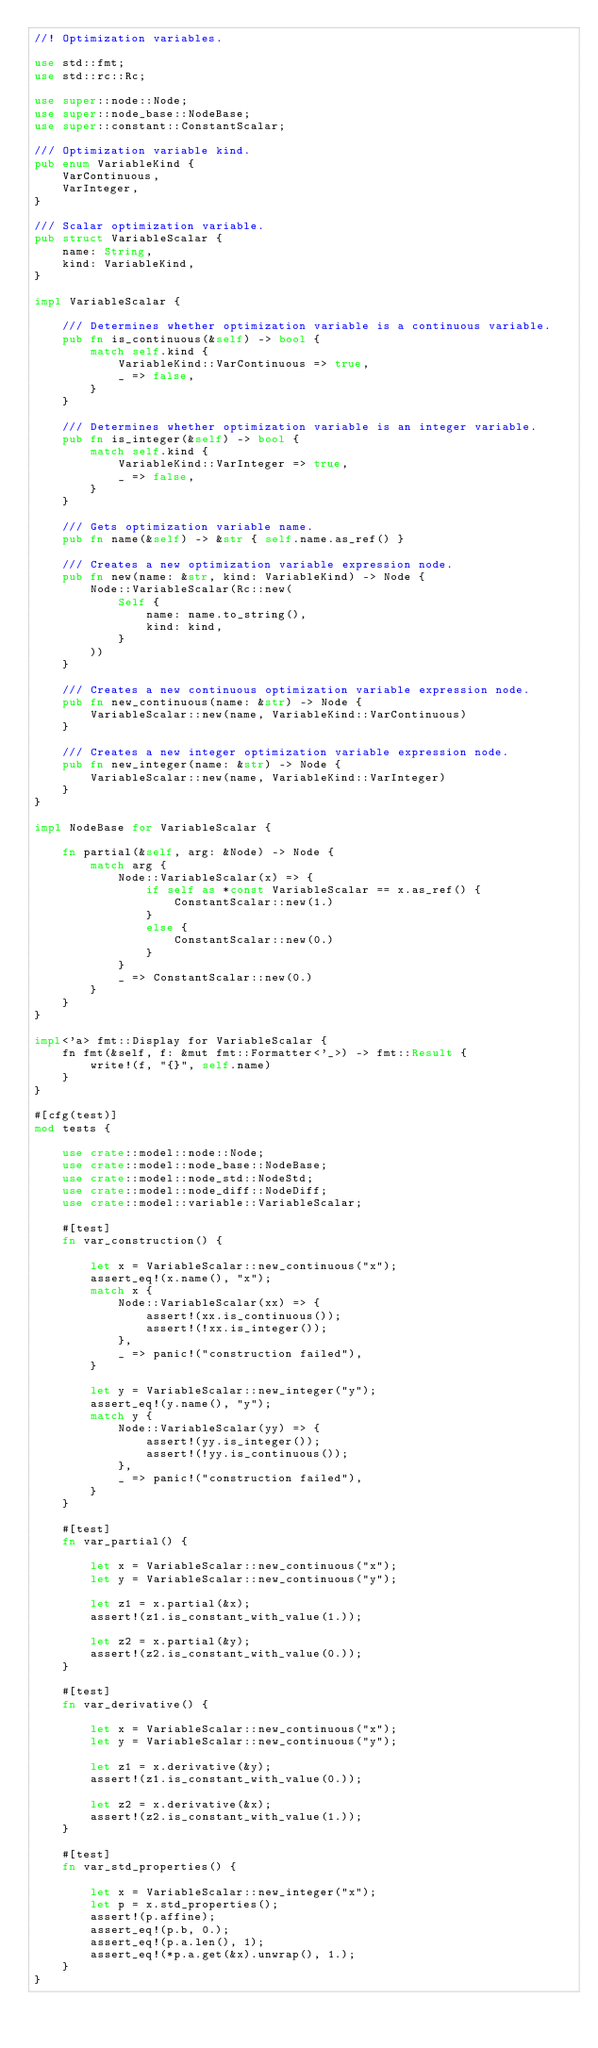<code> <loc_0><loc_0><loc_500><loc_500><_Rust_>//! Optimization variables.

use std::fmt;
use std::rc::Rc;

use super::node::Node;
use super::node_base::NodeBase;
use super::constant::ConstantScalar;

/// Optimization variable kind.
pub enum VariableKind {
    VarContinuous,
    VarInteger,
}

/// Scalar optimization variable.
pub struct VariableScalar {
    name: String,
    kind: VariableKind,
}

impl VariableScalar {

    /// Determines whether optimization variable is a continuous variable.
    pub fn is_continuous(&self) -> bool {
        match self.kind {
            VariableKind::VarContinuous => true,
            _ => false,
        }
    }

    /// Determines whether optimization variable is an integer variable.
    pub fn is_integer(&self) -> bool {
        match self.kind {
            VariableKind::VarInteger => true,
            _ => false,
        }
    }

    /// Gets optimization variable name.
    pub fn name(&self) -> &str { self.name.as_ref() }

    /// Creates a new optimization variable expression node.
    pub fn new(name: &str, kind: VariableKind) -> Node {
        Node::VariableScalar(Rc::new(
            Self {
                name: name.to_string(),
                kind: kind,
            }
        ))
    }

    /// Creates a new continuous optimization variable expression node.
    pub fn new_continuous(name: &str) -> Node {
        VariableScalar::new(name, VariableKind::VarContinuous)
    }

    /// Creates a new integer optimization variable expression node.
    pub fn new_integer(name: &str) -> Node {
        VariableScalar::new(name, VariableKind::VarInteger)
    }
}

impl NodeBase for VariableScalar {

    fn partial(&self, arg: &Node) -> Node { 
        match arg {
            Node::VariableScalar(x) => {
                if self as *const VariableScalar == x.as_ref() {
                    ConstantScalar::new(1.)       
                }
                else {
                    ConstantScalar::new(0.)       
                }
            }
            _ => ConstantScalar::new(0.)  
        }
    }
}

impl<'a> fmt::Display for VariableScalar {
    fn fmt(&self, f: &mut fmt::Formatter<'_>) -> fmt::Result {
        write!(f, "{}", self.name)
    }
}

#[cfg(test)]
mod tests {

    use crate::model::node::Node;
    use crate::model::node_base::NodeBase;
    use crate::model::node_std::NodeStd;
    use crate::model::node_diff::NodeDiff;
    use crate::model::variable::VariableScalar;

    #[test]
    fn var_construction() {

        let x = VariableScalar::new_continuous("x");
        assert_eq!(x.name(), "x");
        match x {
            Node::VariableScalar(xx) => {
                assert!(xx.is_continuous());
                assert!(!xx.is_integer());
            },
            _ => panic!("construction failed"),
        }

        let y = VariableScalar::new_integer("y");
        assert_eq!(y.name(), "y");
        match y {
            Node::VariableScalar(yy) => {
                assert!(yy.is_integer());
                assert!(!yy.is_continuous());
            },
            _ => panic!("construction failed"),
        }
    }

    #[test]
    fn var_partial() {

        let x = VariableScalar::new_continuous("x");
        let y = VariableScalar::new_continuous("y");

        let z1 = x.partial(&x);
        assert!(z1.is_constant_with_value(1.));

        let z2 = x.partial(&y);
        assert!(z2.is_constant_with_value(0.));
    }

    #[test]
    fn var_derivative() {

        let x = VariableScalar::new_continuous("x");
        let y = VariableScalar::new_continuous("y");

        let z1 = x.derivative(&y);
        assert!(z1.is_constant_with_value(0.));

        let z2 = x.derivative(&x);
        assert!(z2.is_constant_with_value(1.));
    }

    #[test]
    fn var_std_properties() {

        let x = VariableScalar::new_integer("x");
        let p = x.std_properties();
        assert!(p.affine);
        assert_eq!(p.b, 0.);
        assert_eq!(p.a.len(), 1);
        assert_eq!(*p.a.get(&x).unwrap(), 1.);
    }
}</code> 